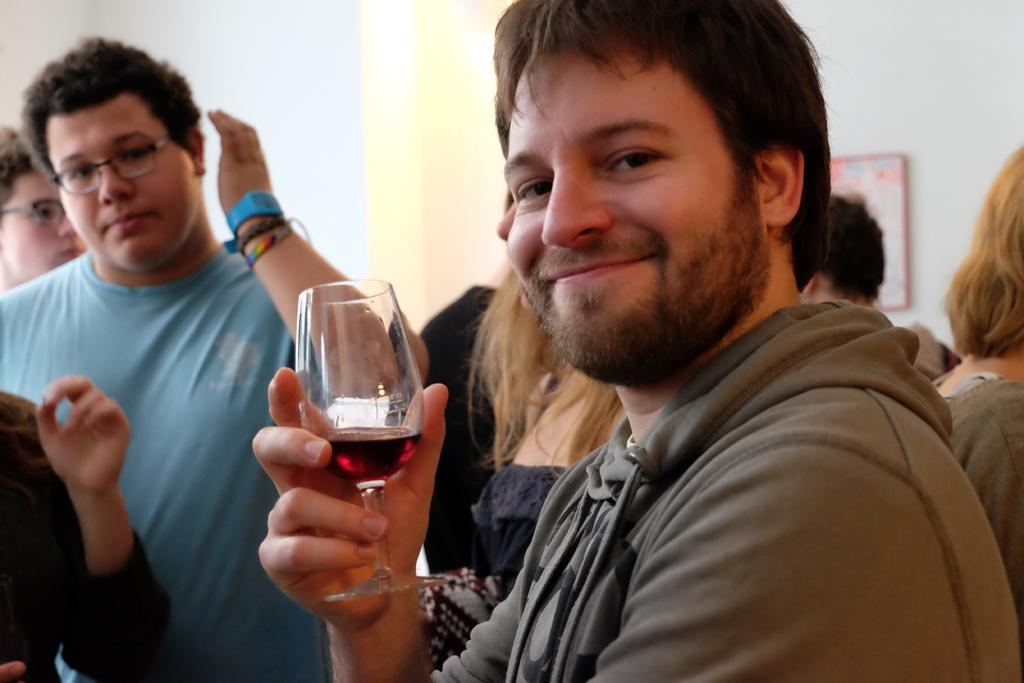What is the person in the image wearing? The person is wearing a grey dress in the image. What is the person holding in the image? The person is holding a glass of wine in the image. Can you describe the people behind the person in the grey dress? There are people behind the person in the grey dress, but their specific appearance or actions are not mentioned in the provided facts. What type of letters is the servant delivering in the image? There is no servant or letters present in the image. What type of insurance policy does the person in the grey dress have? There is no mention of insurance in the image or the provided facts. 